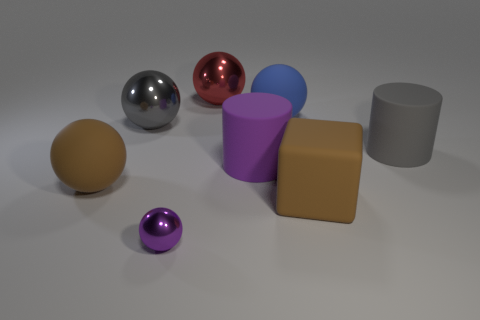Subtract all blue spheres. How many spheres are left? 4 Add 1 big gray cylinders. How many objects exist? 9 Subtract all purple cylinders. How many cylinders are left? 1 Subtract 1 cylinders. How many cylinders are left? 1 Subtract all blue cylinders. Subtract all gray cubes. How many cylinders are left? 2 Subtract all green cylinders. How many purple spheres are left? 1 Subtract all tiny cyan metallic cylinders. Subtract all small metal spheres. How many objects are left? 7 Add 8 gray metallic things. How many gray metallic things are left? 9 Add 7 gray rubber objects. How many gray rubber objects exist? 8 Subtract 0 gray blocks. How many objects are left? 8 